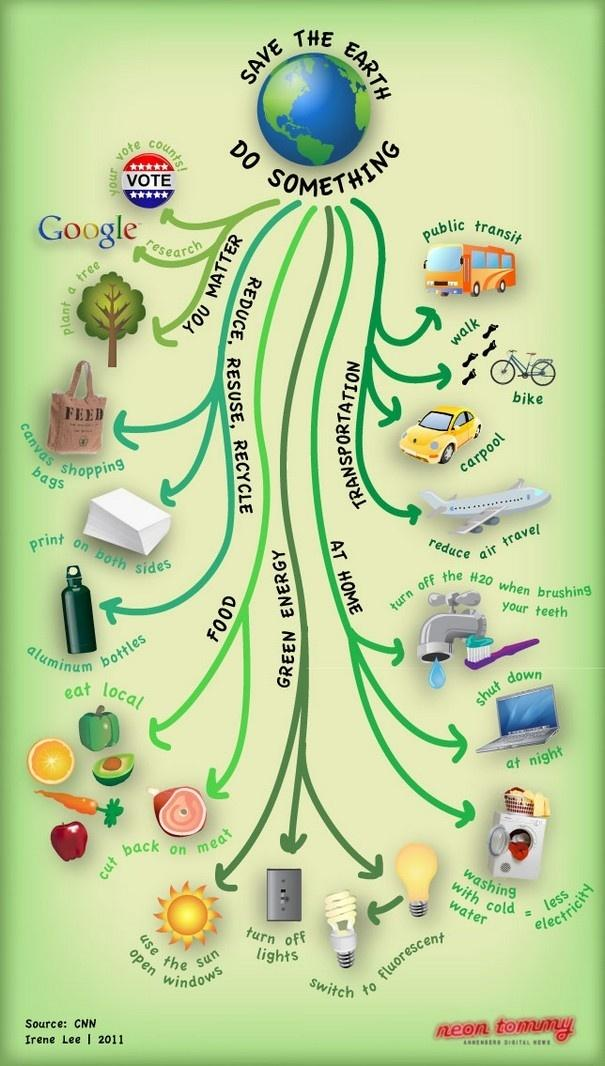List a handful of essential elements in this visual. Meat is the food type that increases the carbon footprint more than fruits and vegetables. The production of greenhouse gases from transportation leads to significant environmental impacts, including climate change. While some forms of transportation, such as cycling and using public transportation, have lower emissions than others, aviation releases the largest amount of greenhouse gases into the atmosphere. Therefore, it is important to reduce our reliance on air travel and consider other forms of transportation that have a lower carbon footprint. The sun is a source of renewable energy. Compact fluorescent light bulbs (CFLs), light-emitting diodes (LEDs), and other technologies also qualify as renewable energy sources. 